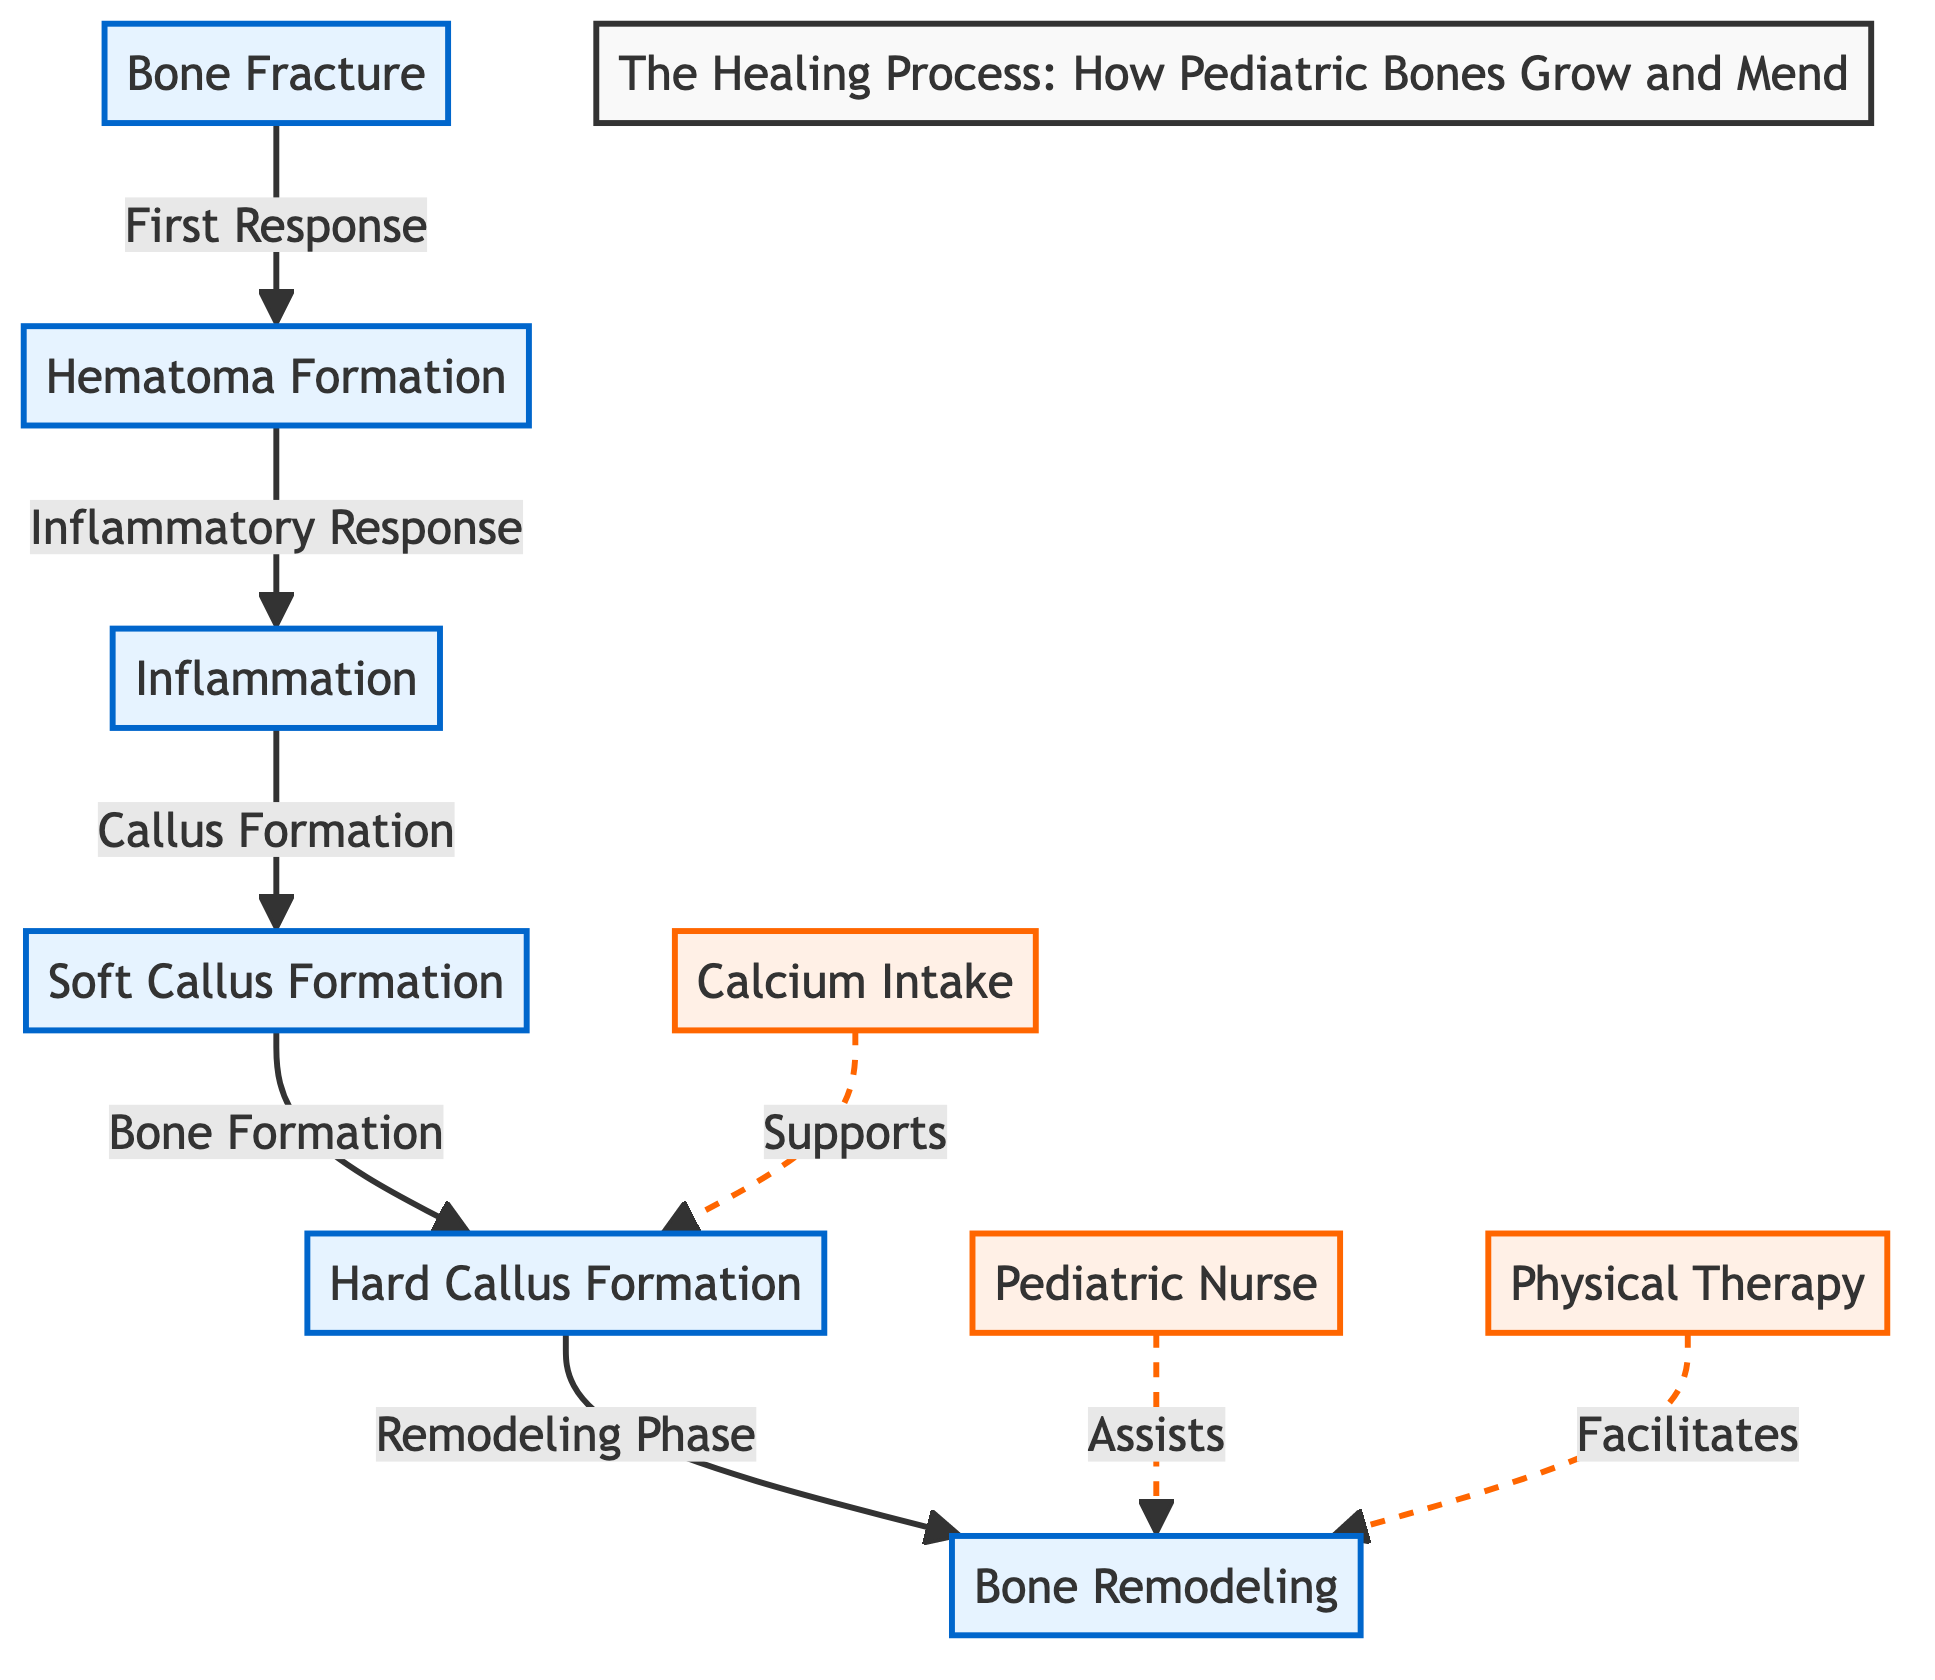What is the first response after a bone fracture? The diagram indicates that the first response after a bone fracture is hematoma formation. This can be seen as the first node connected to the bone fracture.
Answer: hematoma formation How many main phases are there in the healing process? By counting the nodes related to the phases in the diagram (hematoma formation, inflammation, soft callus formation, hard callus formation, and bone remodeling), we find there are five major phases.
Answer: 5 What supports hard callus formation? The diagram shows that calcium intake supports hard callus formation, indicated by the dotted line connecting calcium intake to the hard callus formation node.
Answer: calcium intake Which phase follows inflammation? Referring to the flow of the diagram, inflammation is followed by soft callus formation, as indicated by the arrow pointing from inflammation to soft callus formation.
Answer: soft callus formation What role does the pediatric nurse have in the healing process? The diagram illustrates that the pediatric nurse assists in the bone remodeling phase, which is evident from the dashed line connecting the pediatric nurse to the bone remodeling node.
Answer: Assists What facilitates the bone remodeling process? According to the diagram, physical therapy facilitates the bone remodeling process, as indicated by the dashed line connecting physical therapy to the bone remodeling node.
Answer: Facilitates How does the soft callus formation phase contribute to bone healing? The soft callus formation phase contributes to bone healing as it leads directly to hard callus formation, shown by the arrow that connects both phases in the diagram.
Answer: bone formation Which two nodes are related to the inflammatory response? The nodes related to the inflammatory response are hematoma formation and inflammation, as the progression goes from hematoma formation to inflammation.
Answer: hematoma formation, inflammation What is the last step in the healing process? The last step in the healing process, as shown in the diagram, is bone remodeling, which is the final node in the flowchart.
Answer: bone remodeling 